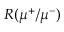<formula> <loc_0><loc_0><loc_500><loc_500>R ( \mu ^ { + } / \mu ^ { - } )</formula> 